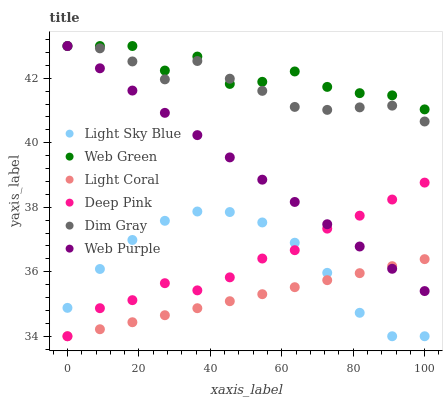Does Light Coral have the minimum area under the curve?
Answer yes or no. Yes. Does Web Green have the maximum area under the curve?
Answer yes or no. Yes. Does Deep Pink have the minimum area under the curve?
Answer yes or no. No. Does Deep Pink have the maximum area under the curve?
Answer yes or no. No. Is Light Coral the smoothest?
Answer yes or no. Yes. Is Web Green the roughest?
Answer yes or no. Yes. Is Deep Pink the smoothest?
Answer yes or no. No. Is Deep Pink the roughest?
Answer yes or no. No. Does Deep Pink have the lowest value?
Answer yes or no. Yes. Does Web Green have the lowest value?
Answer yes or no. No. Does Web Purple have the highest value?
Answer yes or no. Yes. Does Deep Pink have the highest value?
Answer yes or no. No. Is Deep Pink less than Web Green?
Answer yes or no. Yes. Is Dim Gray greater than Deep Pink?
Answer yes or no. Yes. Does Light Sky Blue intersect Deep Pink?
Answer yes or no. Yes. Is Light Sky Blue less than Deep Pink?
Answer yes or no. No. Is Light Sky Blue greater than Deep Pink?
Answer yes or no. No. Does Deep Pink intersect Web Green?
Answer yes or no. No. 